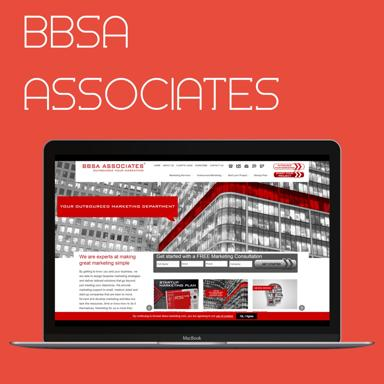What is the company name mentioned on the laptop? The company name prominently displayed on the laptop is 'BBSA Associates'. This logo appears on the top-center of the website that is opened on the laptop screen, indicating that this is likely a corporate laptop or they are viewing their own company website. 